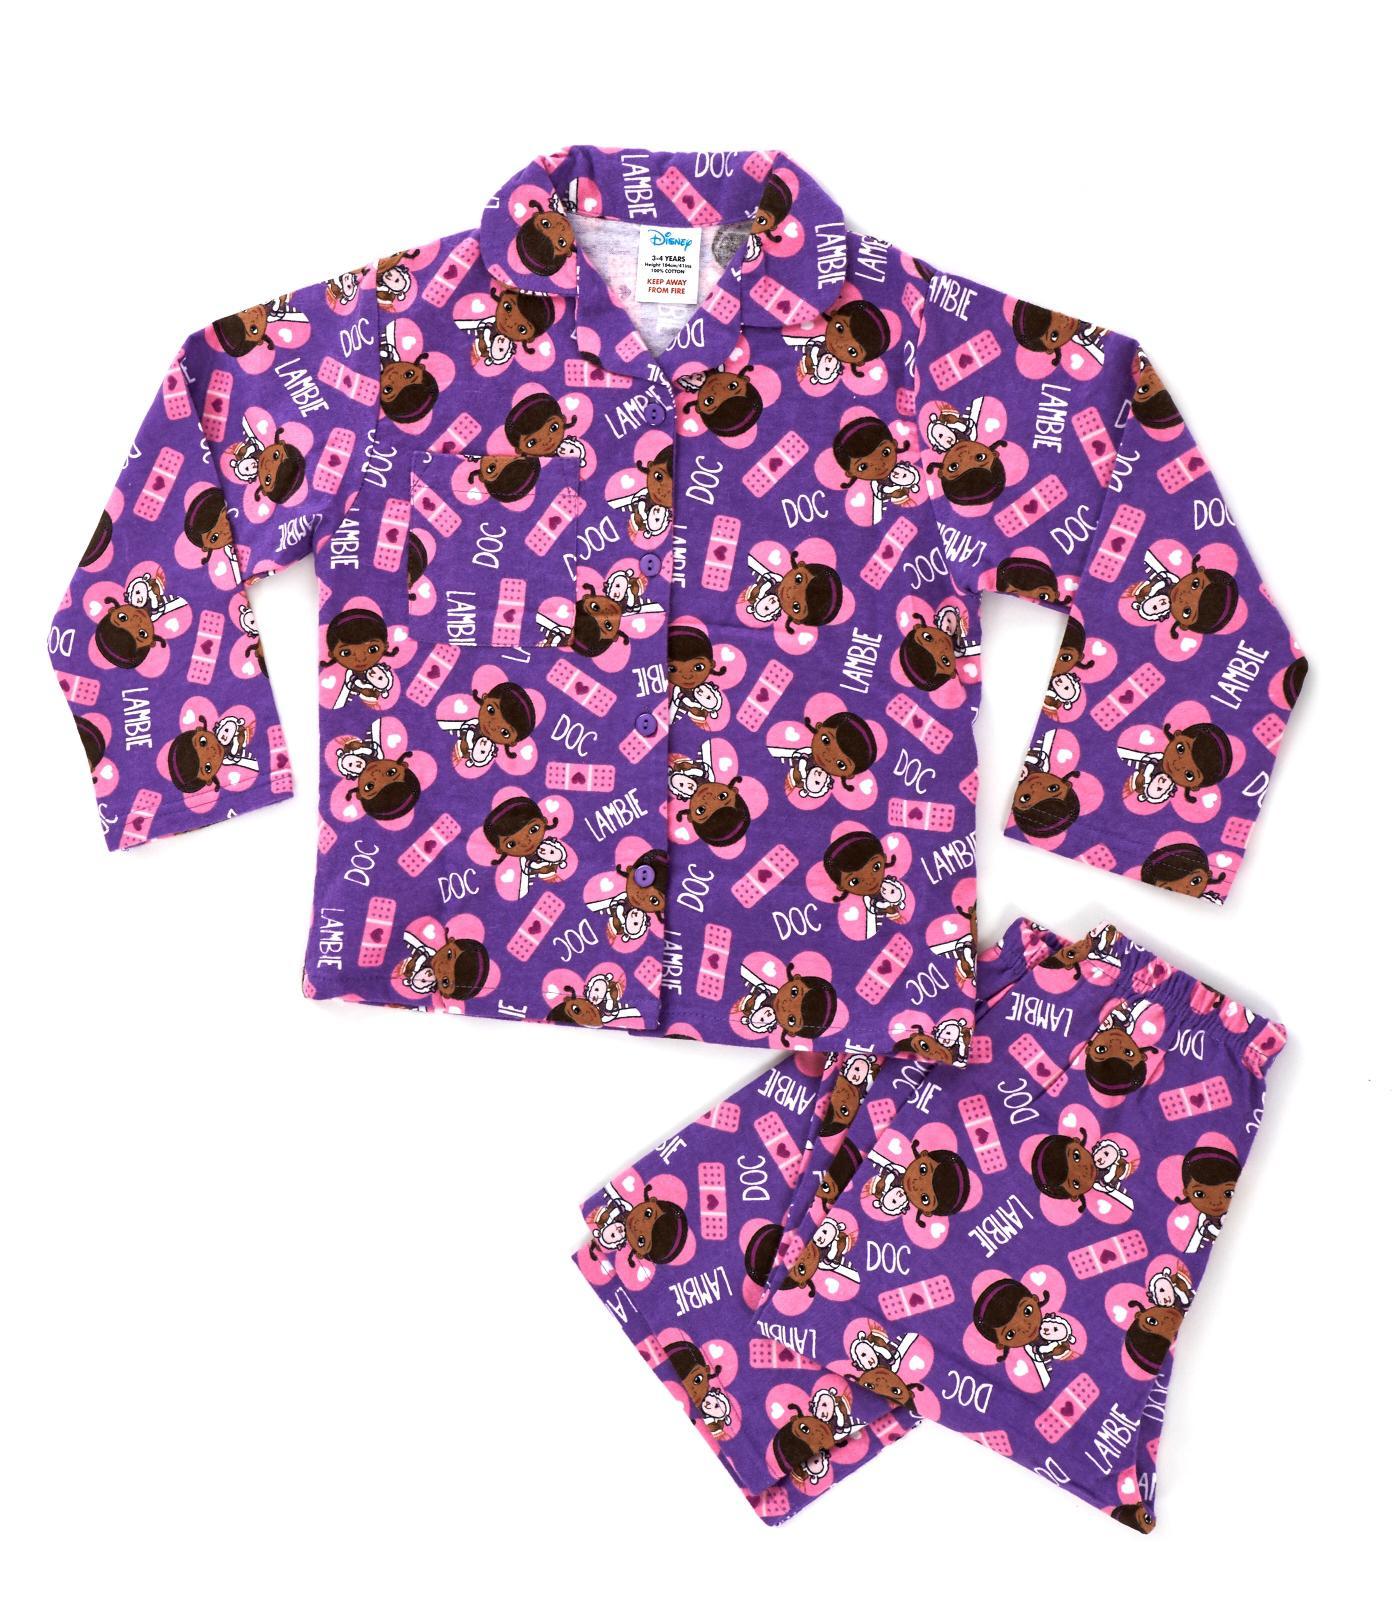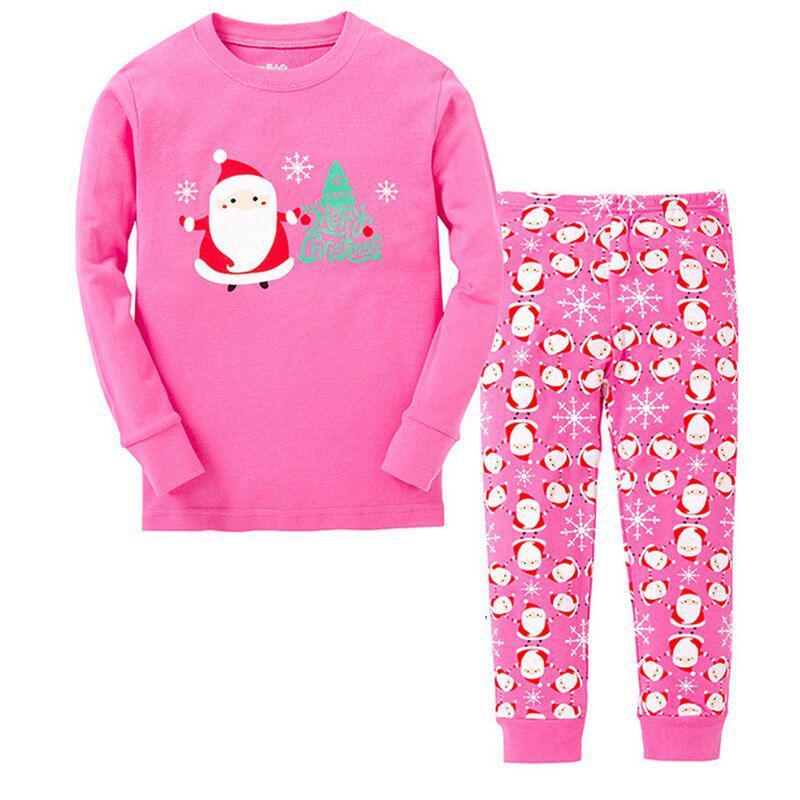The first image is the image on the left, the second image is the image on the right. Assess this claim about the two images: "An image shows a set of loungewear that features a mostly solid-colored long-sleeved top and a coordinating pair of patterned leggings.". Correct or not? Answer yes or no. Yes. The first image is the image on the left, the second image is the image on the right. Evaluate the accuracy of this statement regarding the images: "A two-piece pajama set in one image has a pullover top with applique in the chest area, with wide cuffs on the shirt sleeves and pant legs.". Is it true? Answer yes or no. Yes. 